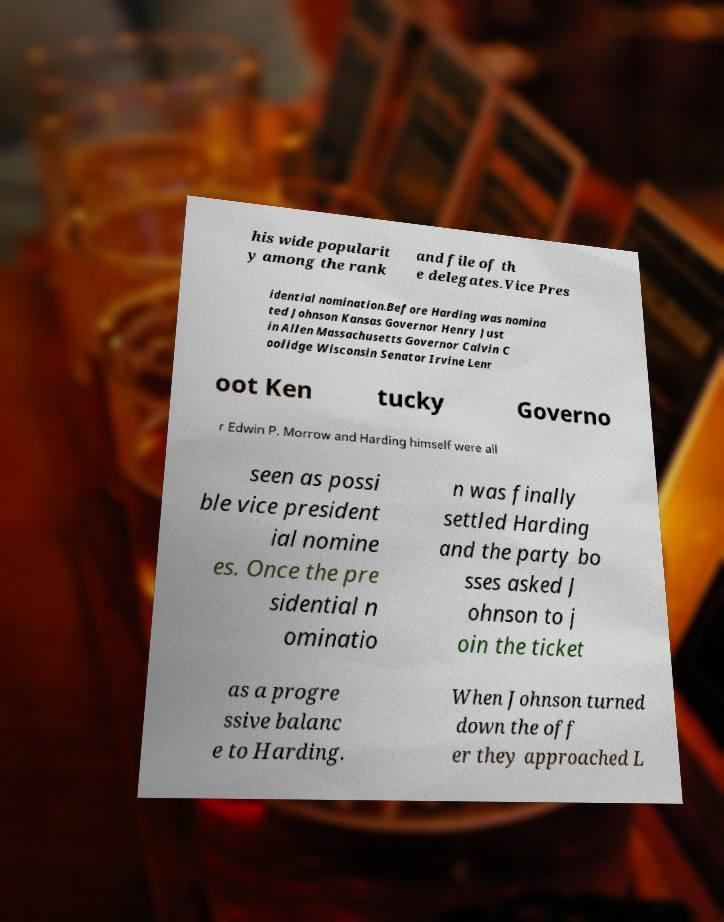Could you assist in decoding the text presented in this image and type it out clearly? his wide popularit y among the rank and file of th e delegates.Vice Pres idential nomination.Before Harding was nomina ted Johnson Kansas Governor Henry Just in Allen Massachusetts Governor Calvin C oolidge Wisconsin Senator Irvine Lenr oot Ken tucky Governo r Edwin P. Morrow and Harding himself were all seen as possi ble vice president ial nomine es. Once the pre sidential n ominatio n was finally settled Harding and the party bo sses asked J ohnson to j oin the ticket as a progre ssive balanc e to Harding. When Johnson turned down the off er they approached L 